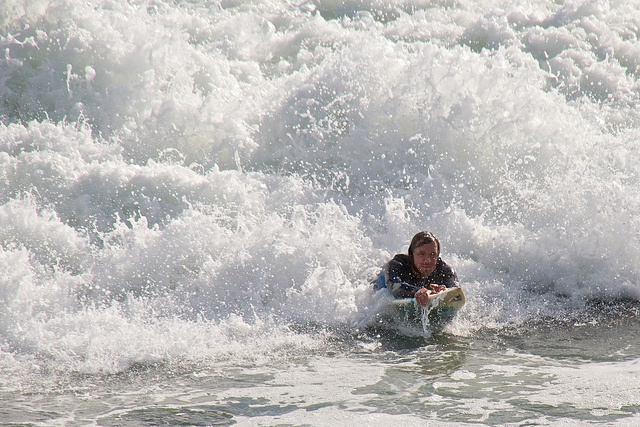Describe the objects in this image and their specific colors. I can see people in lightgray, black, gray, maroon, and darkgray tones and surfboard in lightgray, gray, darkgray, and black tones in this image. 